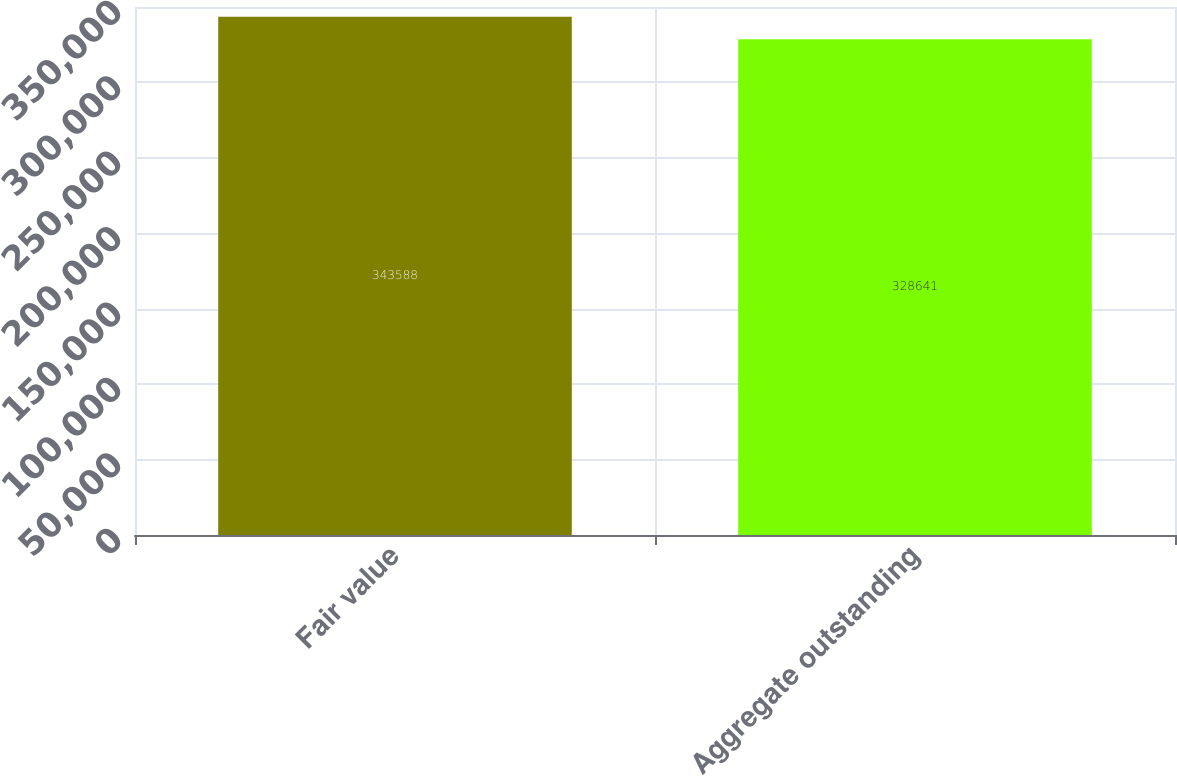Convert chart to OTSL. <chart><loc_0><loc_0><loc_500><loc_500><bar_chart><fcel>Fair value<fcel>Aggregate outstanding<nl><fcel>343588<fcel>328641<nl></chart> 